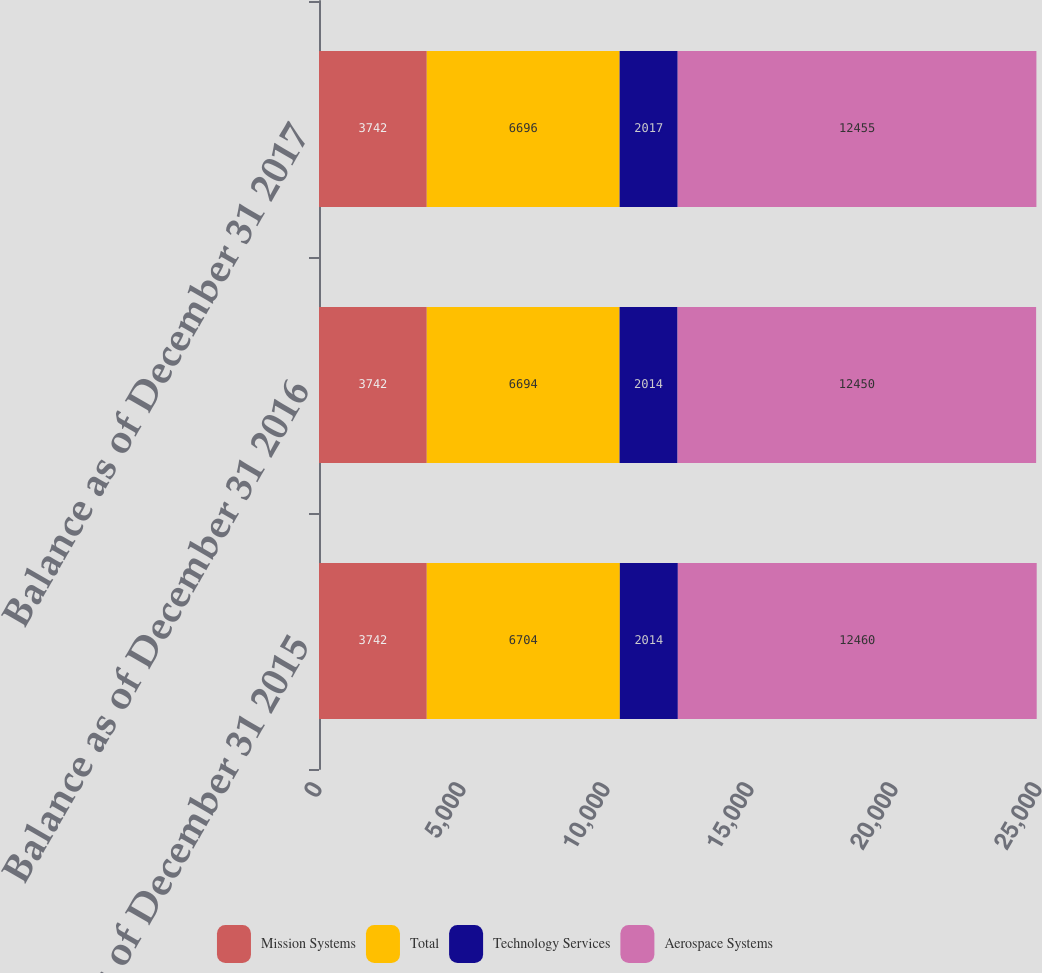Convert chart to OTSL. <chart><loc_0><loc_0><loc_500><loc_500><stacked_bar_chart><ecel><fcel>Balance as of December 31 2015<fcel>Balance as of December 31 2016<fcel>Balance as of December 31 2017<nl><fcel>Mission Systems<fcel>3742<fcel>3742<fcel>3742<nl><fcel>Total<fcel>6704<fcel>6694<fcel>6696<nl><fcel>Technology Services<fcel>2014<fcel>2014<fcel>2017<nl><fcel>Aerospace Systems<fcel>12460<fcel>12450<fcel>12455<nl></chart> 